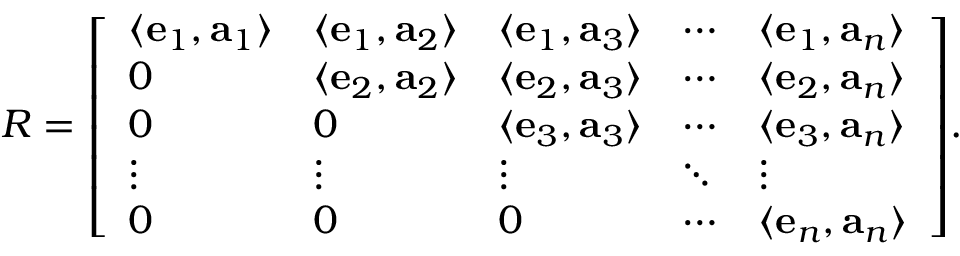<formula> <loc_0><loc_0><loc_500><loc_500>R = { \left [ \begin{array} { l l l l l } { \langle e _ { 1 } , a _ { 1 } \rangle } & { \langle e _ { 1 } , a _ { 2 } \rangle } & { \langle e _ { 1 } , a _ { 3 } \rangle } & { \cdots } & { \langle e _ { 1 } , a _ { n } \rangle } \\ { 0 } & { \langle e _ { 2 } , a _ { 2 } \rangle } & { \langle e _ { 2 } , a _ { 3 } \rangle } & { \cdots } & { \langle e _ { 2 } , a _ { n } \rangle } \\ { 0 } & { 0 } & { \langle e _ { 3 } , a _ { 3 } \rangle } & { \cdots } & { \langle e _ { 3 } , a _ { n } \rangle } \\ { \vdots } & { \vdots } & { \vdots } & { \ddots } & { \vdots } \\ { 0 } & { 0 } & { 0 } & { \cdots } & { \langle e _ { n } , a _ { n } \rangle } \end{array} \right ] } .</formula> 